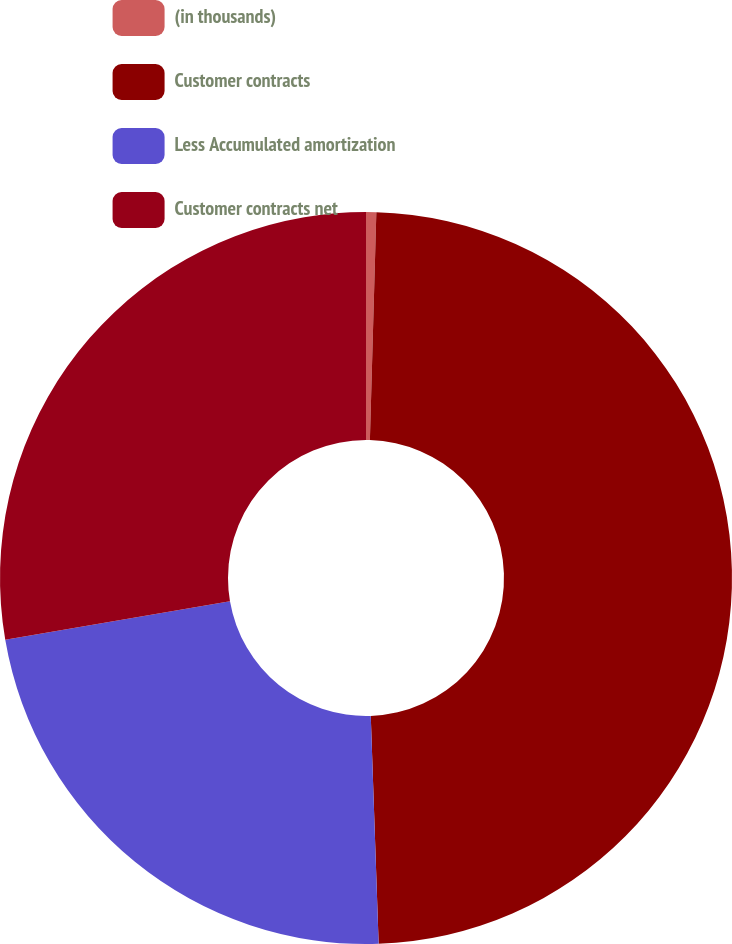Convert chart. <chart><loc_0><loc_0><loc_500><loc_500><pie_chart><fcel>(in thousands)<fcel>Customer contracts<fcel>Less Accumulated amortization<fcel>Customer contracts net<nl><fcel>0.45%<fcel>49.0%<fcel>22.85%<fcel>27.7%<nl></chart> 